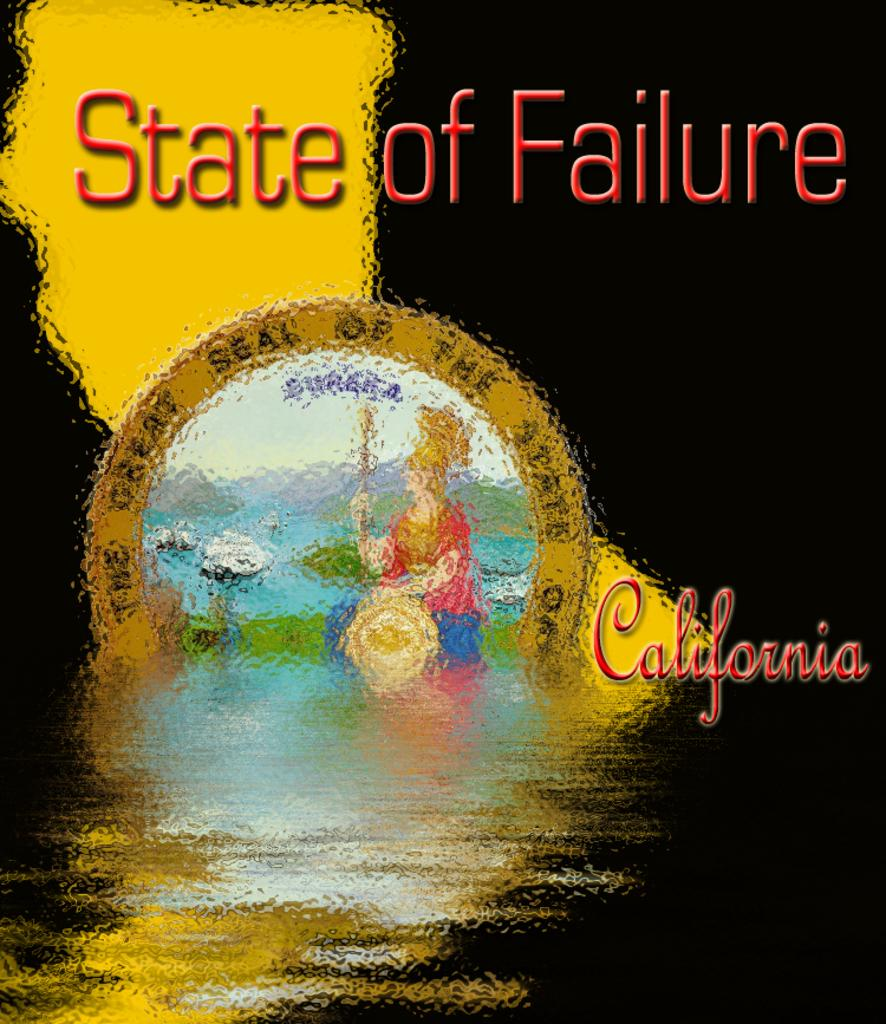<image>
Share a concise interpretation of the image provided. a poster that has state of failure written on it 